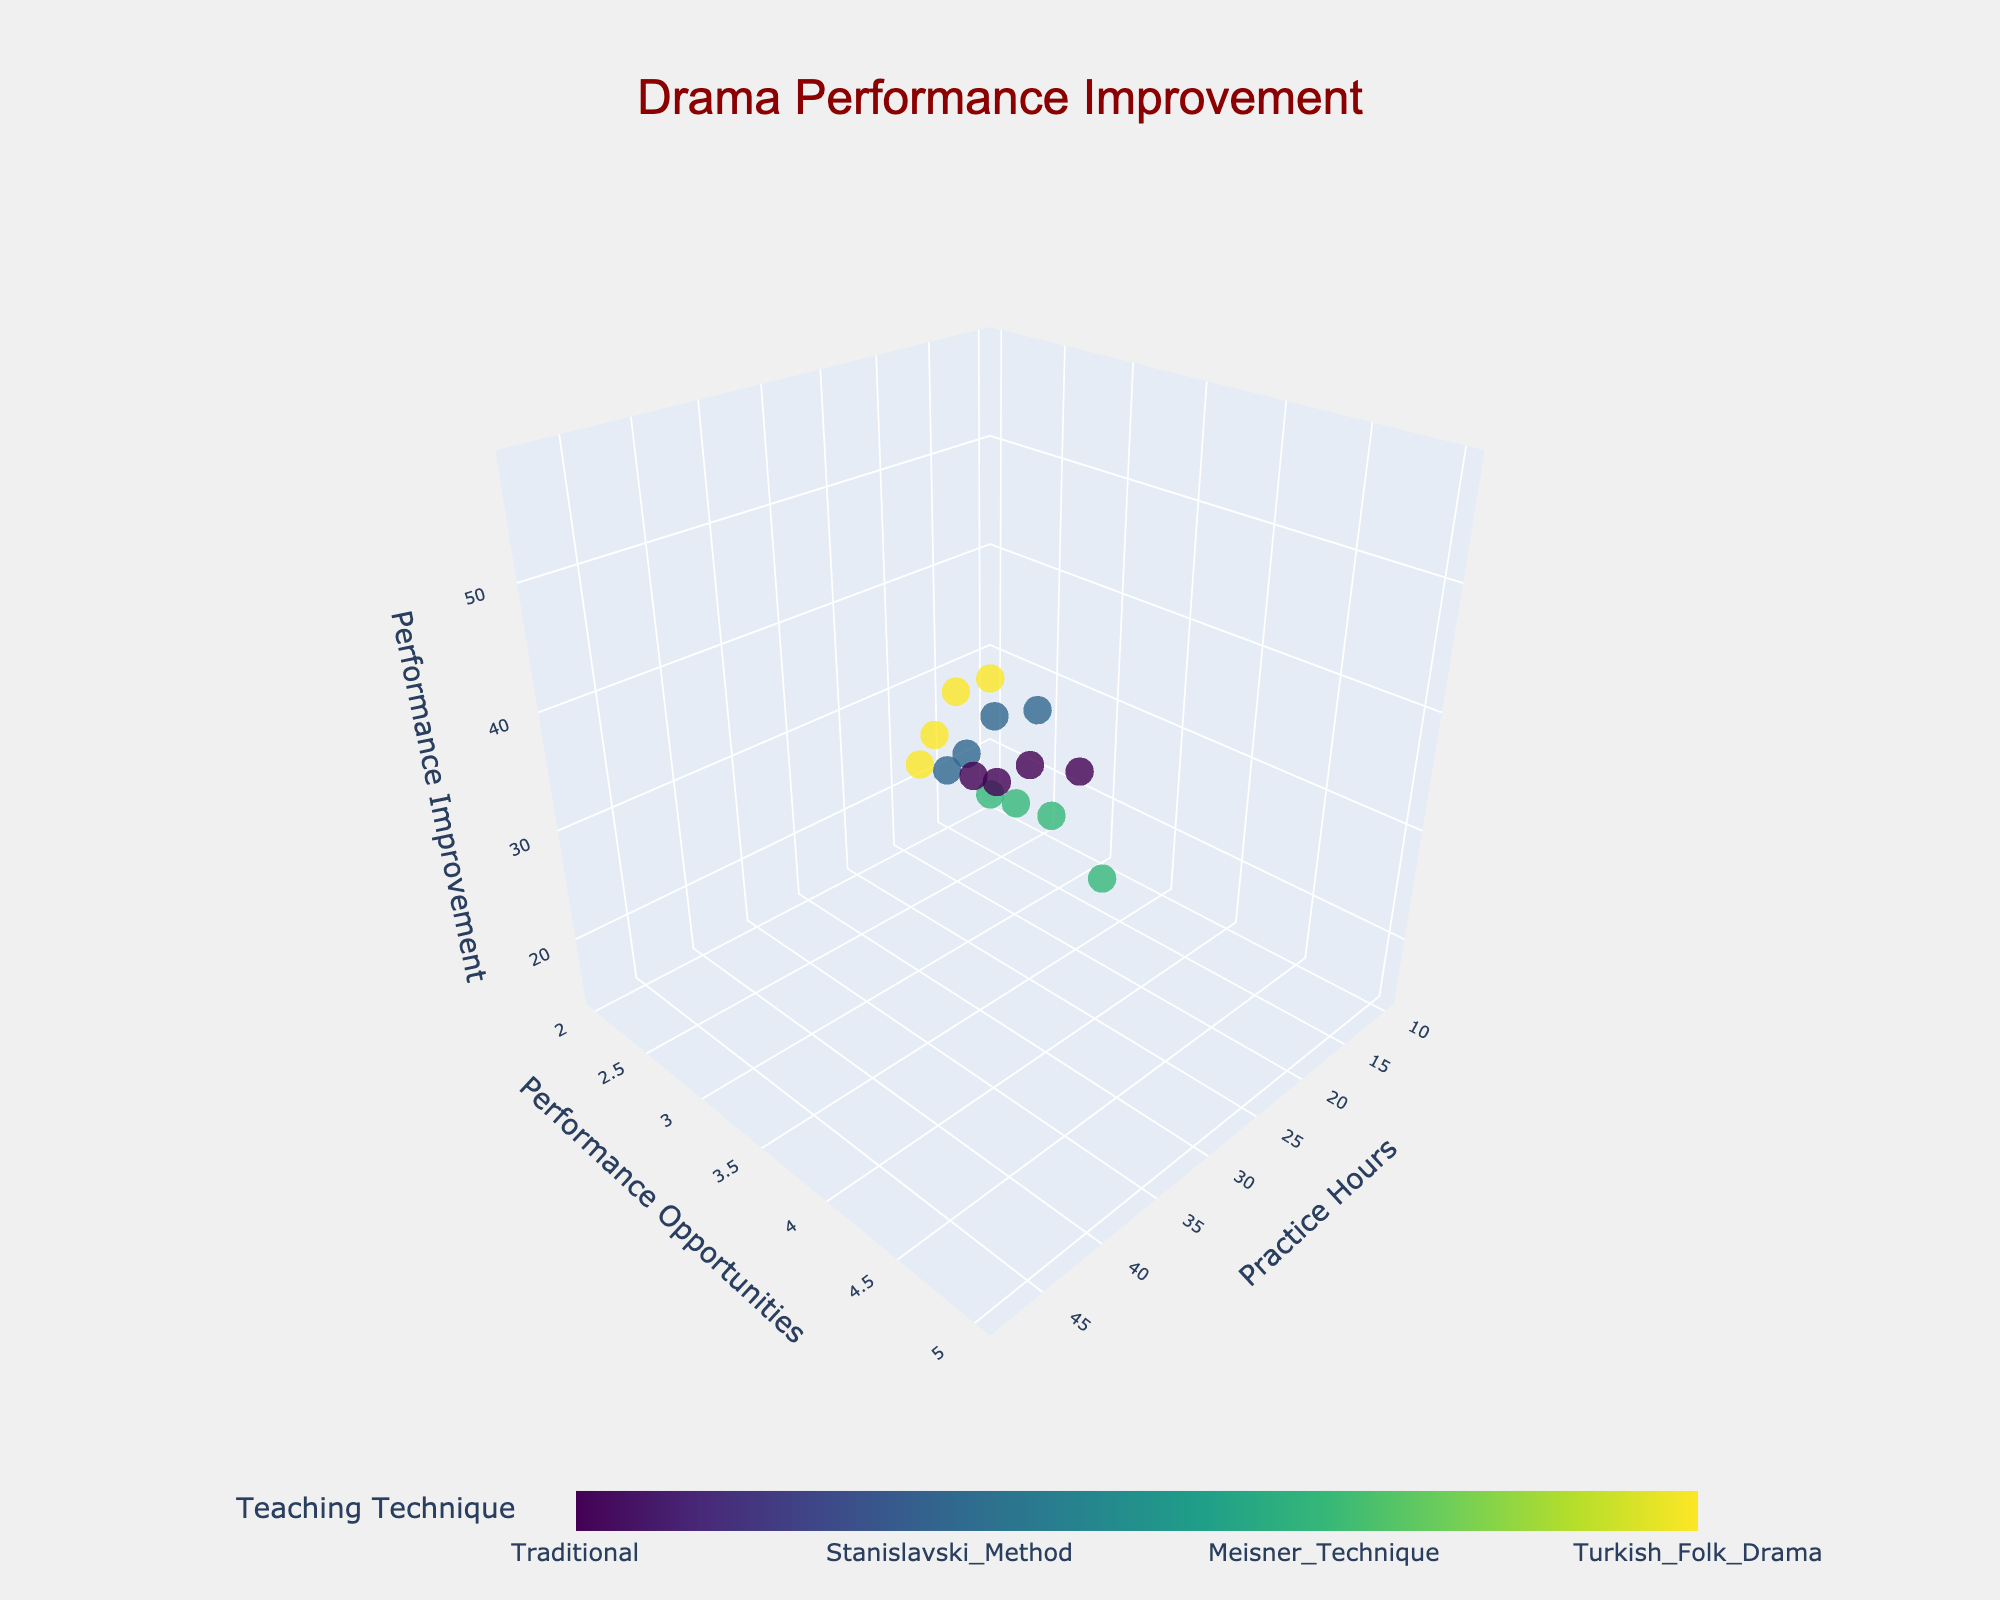What is the title of the plot? The title is usually centered at the top of the figure. It helps to quickly identify the topic of the plot.
Answer: Drama Performance Improvement How many different teaching techniques are represented in the plot? By observing the color bar legend, you can count the distinct categories listed under "Teaching Technique".
Answer: 4 Which axis represents Performance Improvement? Look at the axis labels. The axis labelled as "Performance Improvement" will represent Performance Improvement.
Answer: The z-axis Which data point has the highest Performance Improvement? Identify the point on the z-axis with the highest value, referring to the Performance Improvement axis.
Answer: Turkish Folk Drama, Practice Hours = 48, Performance Opportunities = 5 What is the range of Practice Hours shown in the plot? Look at the minimum and maximum values on the x-axis labelled "Practice Hours".
Answer: 10 to 48 How does the number of Performance Opportunities generally affect Performance Improvement? Observe the trend in Performance Improvement as Performance Opportunities increase (moving along the y-axis). Generally, Performance Improvement increases as Performance Opportunities increase.
Answer: Generally increases Which teaching technique has the highest average Performance Improvement? Calculate the average Performance Improvement for each technique, then compare these averages.
Answer: Turkish Folk Drama Between Traditional and Stanislavski Method techniques, which one shows better improvement for 30 Practice Hours and 4 Performance Opportunities? Find the data points for 30 Practice Hours and 4 Performance Opportunities for both techniques and compare their Performance Improvement values.
Answer: Stanislavski Method What color scale is used in the plot? Observing the figure, the color scale provides a clue about the range of hues used.
Answer: Viridis How are the data points visually differentiated based on teaching techniques? Notice the markers in the plot. Each teaching technique is represented by a different color as indicated by the color bar.
Answer: By color 